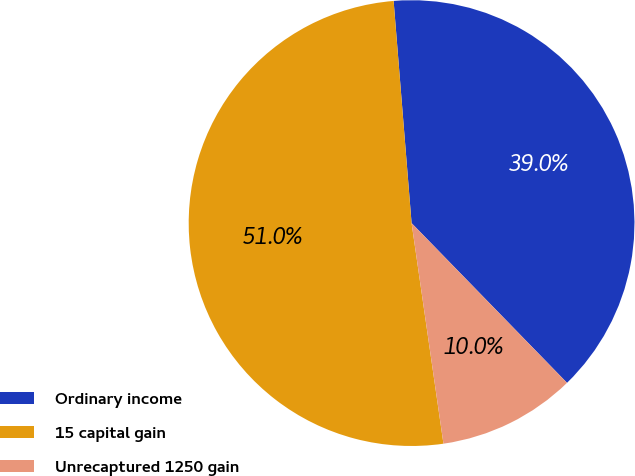<chart> <loc_0><loc_0><loc_500><loc_500><pie_chart><fcel>Ordinary income<fcel>15 capital gain<fcel>Unrecaptured 1250 gain<nl><fcel>39.0%<fcel>51.0%<fcel>10.0%<nl></chart> 